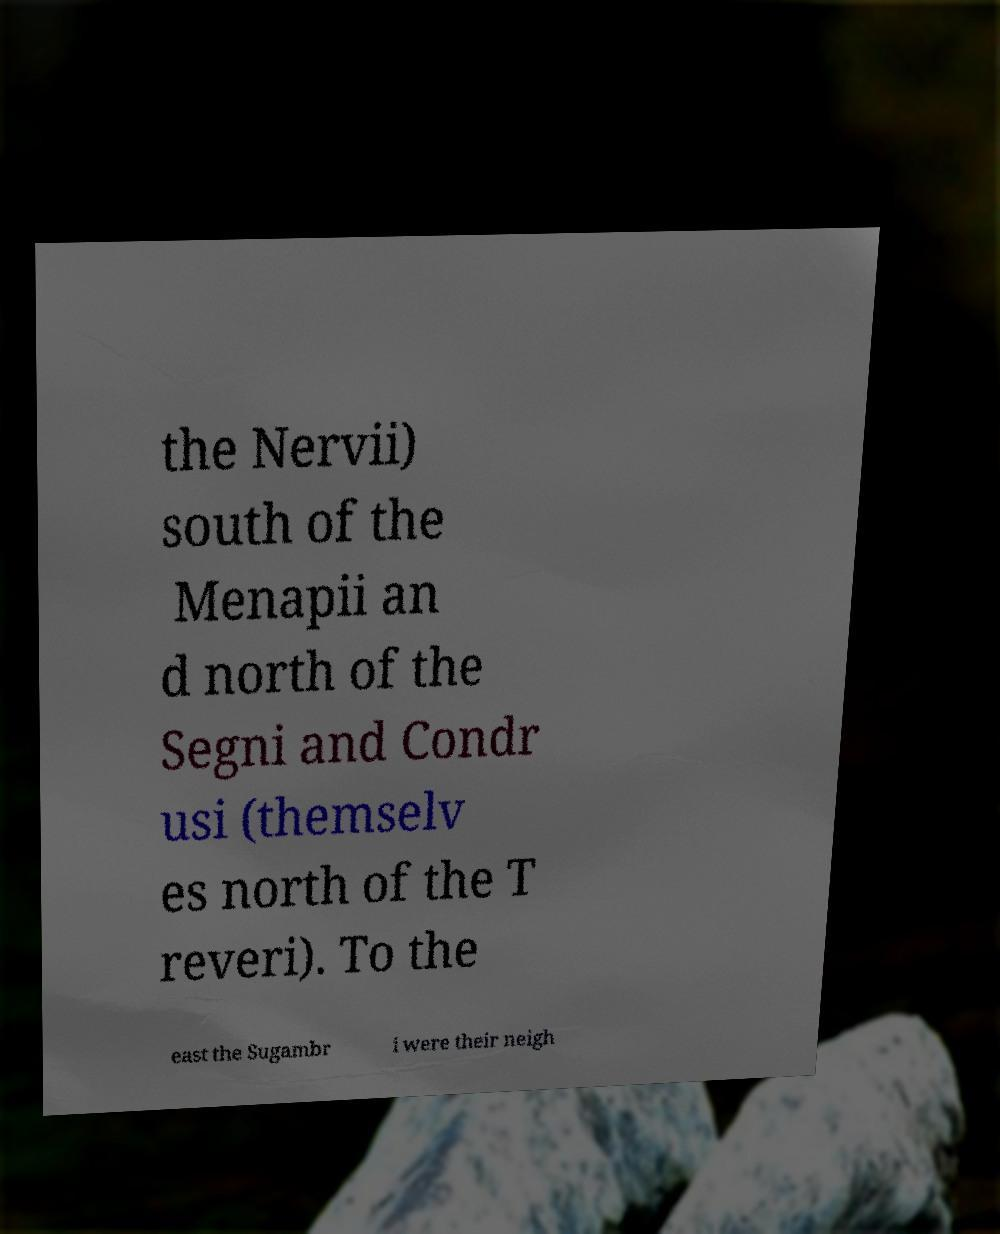Can you read and provide the text displayed in the image?This photo seems to have some interesting text. Can you extract and type it out for me? the Nervii) south of the Menapii an d north of the Segni and Condr usi (themselv es north of the T reveri). To the east the Sugambr i were their neigh 